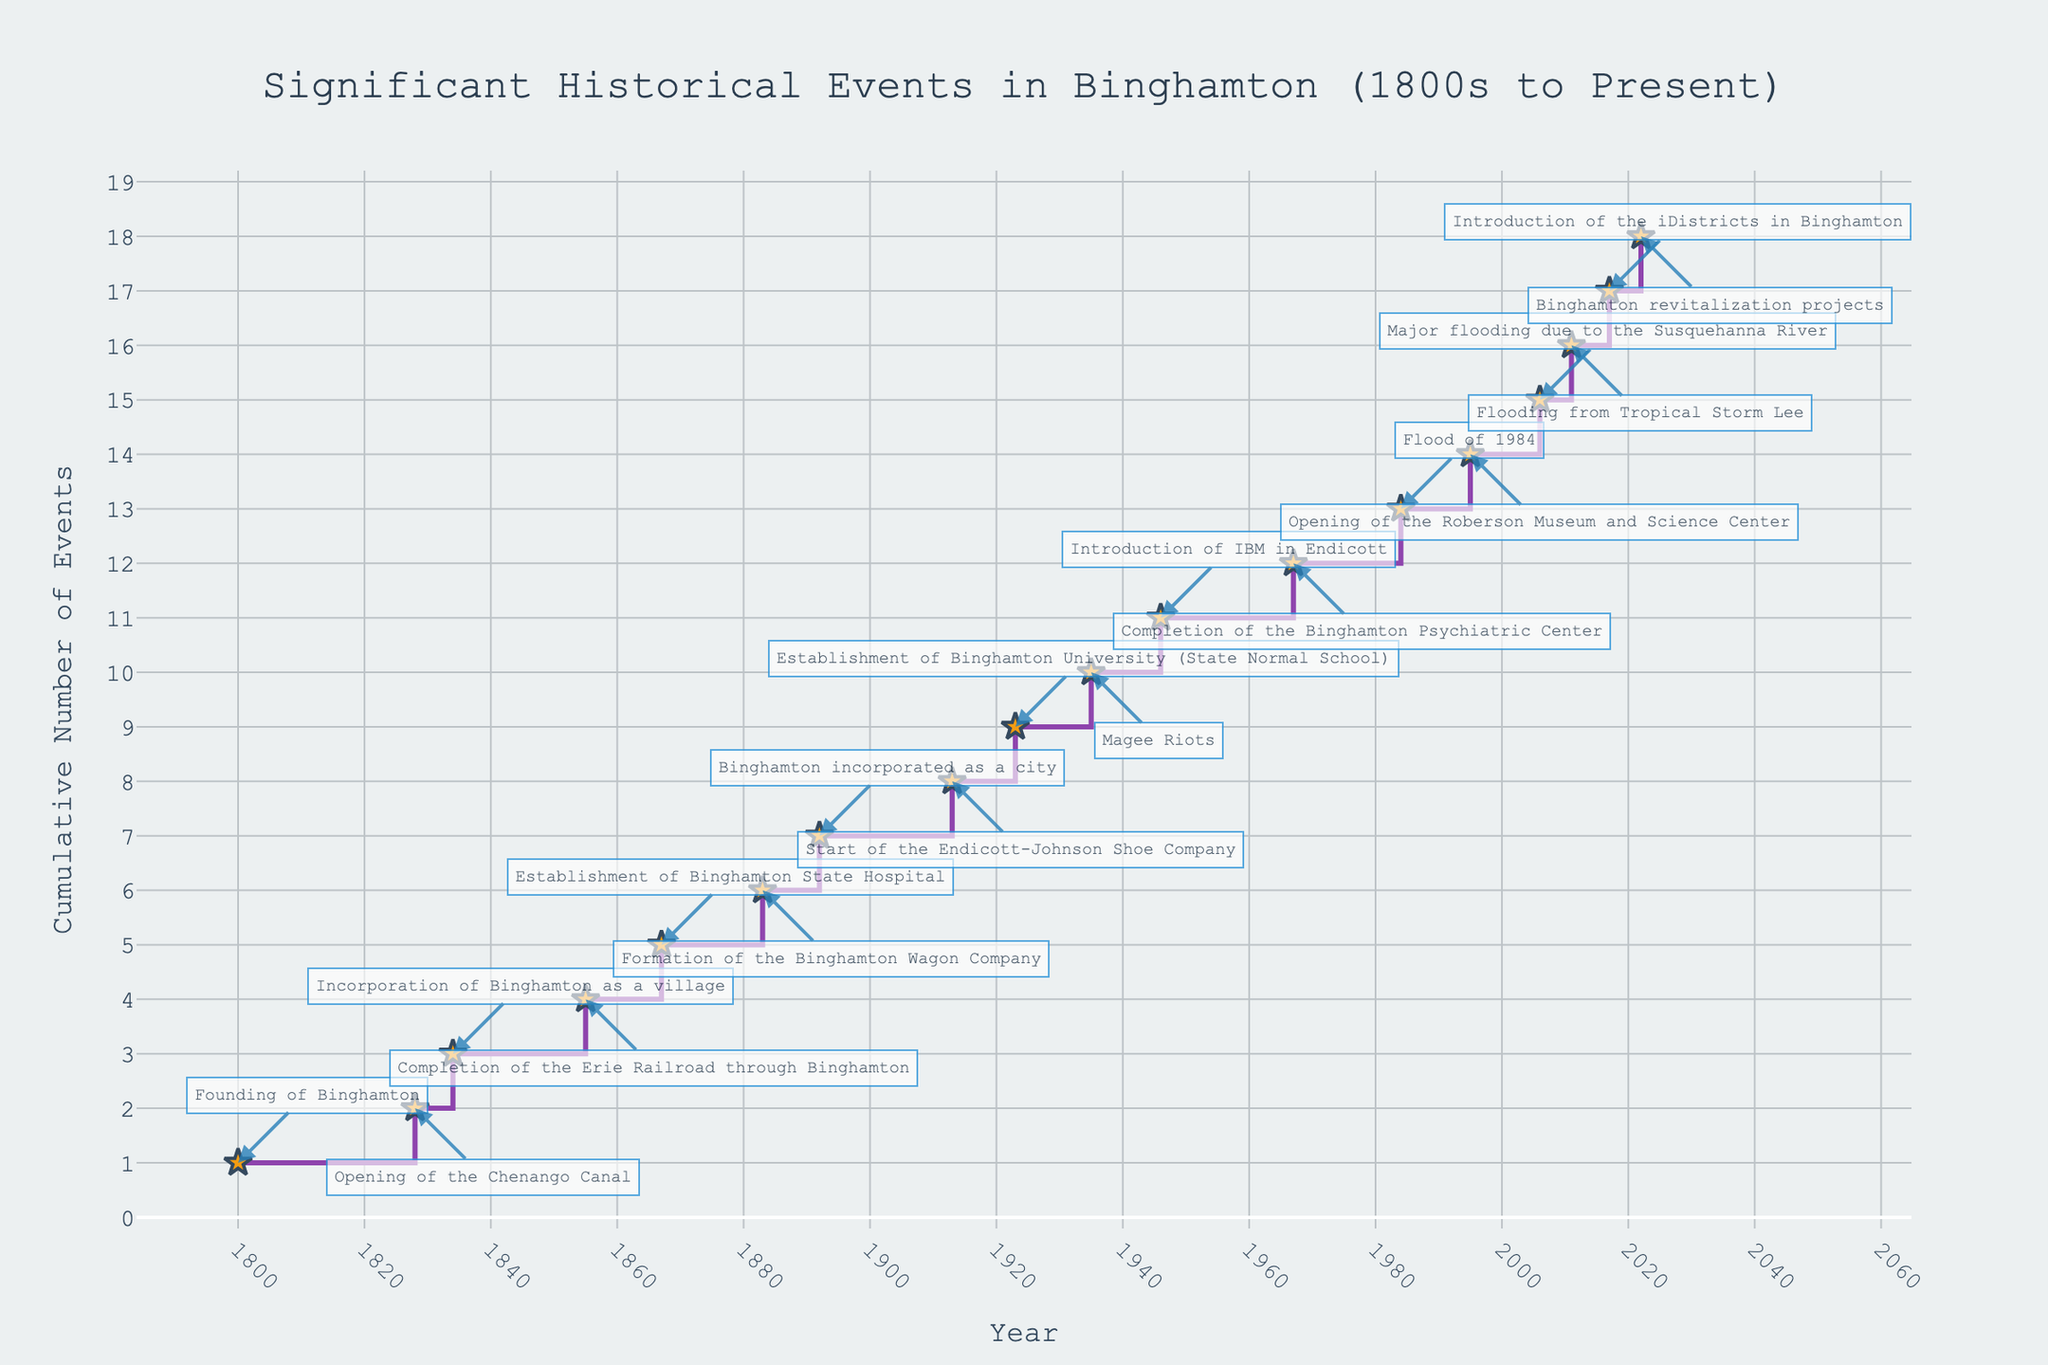What's the title of the figure? The title is usually presented at the top of the figure. In this case, it is given as 'Significant Historical Events in Binghamton (1800s to Present)'.
Answer: Significant Historical Events in Binghamton (1800s to Present) What do the x-axis and y-axis represent? The x-axis usually indicates the time or categories, and the y-axis often represents the numerical values. Here, the x-axis represents the 'Year' and the y-axis represents the 'Cumulative Number of Events'.
Answer: Year and Cumulative Number of Events How many significant historical events occurred in Binghamton between 1800 and 1900? By counting the steps in the plot between 1800 and 1900, we can find the number of events. According to the data, the events span from 1800 (Founding of Binghamton) to 1892 (Binghamton incorporated as a city). There are six events within this range.
Answer: 6 Between which two years did the largest gap in significant historical events occur? Examine the plot for the longest horizontal line segment, which indicates the years between events. The largest gap appears between 1923 (Establishment of Binghamton University) and 1935 (Magee Riots), spanning 12 years.
Answer: 1923 and 1935 What is the cumulative number of significant events by the year 2000? Identify the last step before the year 2000. According to the data, the events up until 1995 are considered. The cumulative number by 1995 is 13.
Answer: 13 Which event took place in 1923, and what was its cumulative event count by that year? Locate the specific year and read the annotation. The event is the 'Establishment of Binghamton University (State Normal School)', with a cumulative count of 9 by that year (1923).
Answer: Establishment of Binghamton University, 9 Compare the cumulative number of events in the 19th century to the 20th century. The 19th century (up to 1900) has 6 events, and the 20th century (1901-2000) has 7 events based on cumulative counts at those years.
Answer: 6 in the 19th Century, 7 in the 20th Century How does the frequency of significant events change over time? Inspect the density of the steps. Initially, events occur sporadically, with increased frequency in the late 19th and 20th centuries. Recent years also show a slight increase in the number of events.
Answer: Increases over time, especially in the late 19th and 20th centuries When did the introduction of IBM in Endicott occur, and what was the cumulative count before and after this event? The introduction of IBM in Endicott occurred in 1946. The cumulative count before 1946 was 9, and after the event, it is 10.
Answer: 1946, 9 before, 10 after 